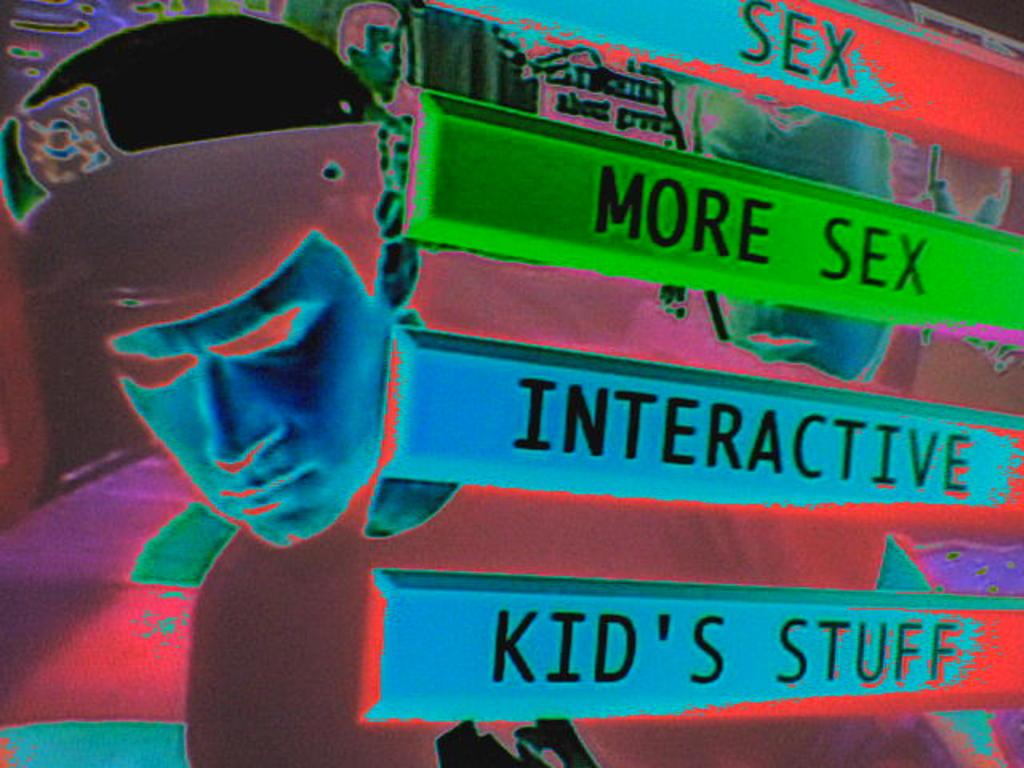What is the main subject of the image? The main subject of the image is a person's face. What else can be seen in the image besides the person's face? There are bars with text in the image. Can you see any fowl in the image? There is no fowl present in the image. How does the person in the image walk? The image only shows a person's face, so it is not possible to determine how the person walks. 